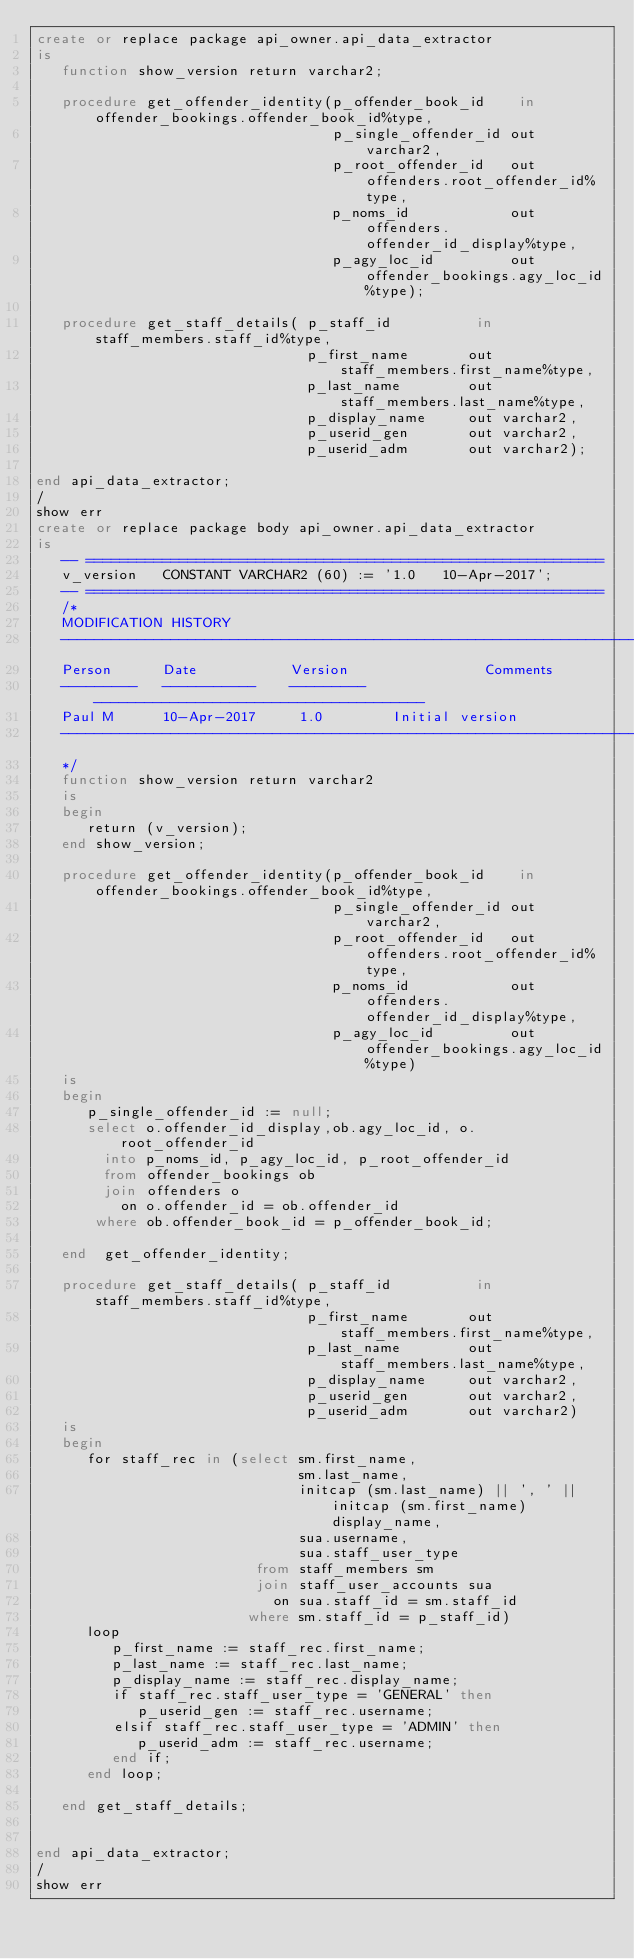Convert code to text. <code><loc_0><loc_0><loc_500><loc_500><_SQL_>create or replace package api_owner.api_data_extractor
is
   function show_version return varchar2;

   procedure get_offender_identity(p_offender_book_id    in offender_bookings.offender_book_id%type,
                                   p_single_offender_id out varchar2,
                                   p_root_offender_id   out offenders.root_offender_id%type,
                                   p_noms_id            out offenders.offender_id_display%type,
                                   p_agy_loc_id         out offender_bookings.agy_loc_id%type);

   procedure get_staff_details( p_staff_id          in staff_members.staff_id%type,
                                p_first_name       out staff_members.first_name%type,
                                p_last_name        out staff_members.last_name%type,
                                p_display_name     out varchar2,
                                p_userid_gen       out varchar2,
                                p_userid_adm       out varchar2);

end api_data_extractor;
/
show err
create or replace package body api_owner.api_data_extractor
is
   -- =============================================================
   v_version   CONSTANT VARCHAR2 (60) := '1.0   10-Apr-2017';
   -- =============================================================
   /*
   MODIFICATION HISTORY
   ------------------------------------------------------------------------------
   Person      Date           Version                Comments
   ---------   -----------    ---------   ---------------------------------------
   Paul M      10-Apr-2017     1.0        Initial version
   ------------------------------------------------------------------------------
   */
   function show_version return varchar2
   is
   begin
      return (v_version);
   end show_version;

   procedure get_offender_identity(p_offender_book_id    in offender_bookings.offender_book_id%type,
                                   p_single_offender_id out varchar2,
                                   p_root_offender_id   out offenders.root_offender_id%type,
                                   p_noms_id            out offenders.offender_id_display%type,
                                   p_agy_loc_id         out offender_bookings.agy_loc_id%type)
   is
   begin
      p_single_offender_id := null;
      select o.offender_id_display,ob.agy_loc_id, o.root_offender_id
        into p_noms_id, p_agy_loc_id, p_root_offender_id
        from offender_bookings ob
        join offenders o
          on o.offender_id = ob.offender_id
       where ob.offender_book_id = p_offender_book_id;

   end  get_offender_identity;

   procedure get_staff_details( p_staff_id          in staff_members.staff_id%type,
                                p_first_name       out staff_members.first_name%type,
                                p_last_name        out staff_members.last_name%type,
                                p_display_name     out varchar2,
                                p_userid_gen       out varchar2,
                                p_userid_adm       out varchar2)
   is
   begin
      for staff_rec in (select sm.first_name,
                               sm.last_name,
                               initcap (sm.last_name) || ', ' || initcap (sm.first_name) display_name,
                               sua.username,
                               sua.staff_user_type
                          from staff_members sm
                          join staff_user_accounts sua
                            on sua.staff_id = sm.staff_id
                         where sm.staff_id = p_staff_id)
      loop
         p_first_name := staff_rec.first_name;
         p_last_name := staff_rec.last_name;
         p_display_name := staff_rec.display_name;
         if staff_rec.staff_user_type = 'GENERAL' then
            p_userid_gen := staff_rec.username;
         elsif staff_rec.staff_user_type = 'ADMIN' then
            p_userid_adm := staff_rec.username;
         end if;
      end loop;

   end get_staff_details;


end api_data_extractor;
/
show err
</code> 